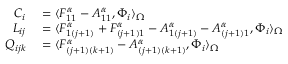Convert formula to latex. <formula><loc_0><loc_0><loc_500><loc_500>\begin{array} { r l } { C _ { i } } & = \langle F _ { 1 1 } ^ { \alpha } - A _ { 1 1 } ^ { \alpha } , \Phi _ { i } \rangle _ { \Omega } } \\ { L _ { i j } } & = \langle F _ { 1 ( j + 1 ) } ^ { \alpha } + F _ { ( j + 1 ) 1 } ^ { \alpha } - A _ { 1 ( j + 1 ) } ^ { \alpha } - A _ { ( j + 1 ) 1 } ^ { \alpha } , \Phi _ { i } \rangle _ { \Omega } } \\ { Q _ { i j k } } & = \langle F _ { ( j + 1 ) ( k + 1 ) } ^ { \alpha } - A _ { ( j + 1 ) ( k + 1 ) } ^ { \alpha } , \Phi _ { i } \rangle _ { \Omega } } \end{array}</formula> 